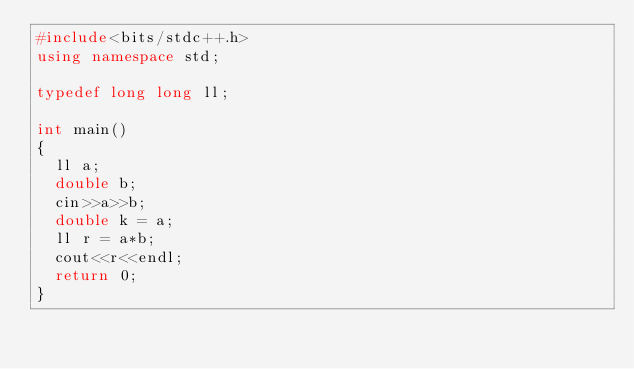Convert code to text. <code><loc_0><loc_0><loc_500><loc_500><_C++_>#include<bits/stdc++.h>
using namespace std;

typedef long long ll;

int main()
{
  ll a;
  double b;
  cin>>a>>b;
  double k = a;
  ll r = a*b;
  cout<<r<<endl;
  return 0;
}</code> 